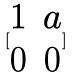Convert formula to latex. <formula><loc_0><loc_0><loc_500><loc_500>[ \begin{matrix} 1 & a \\ 0 & 0 \end{matrix} ]</formula> 